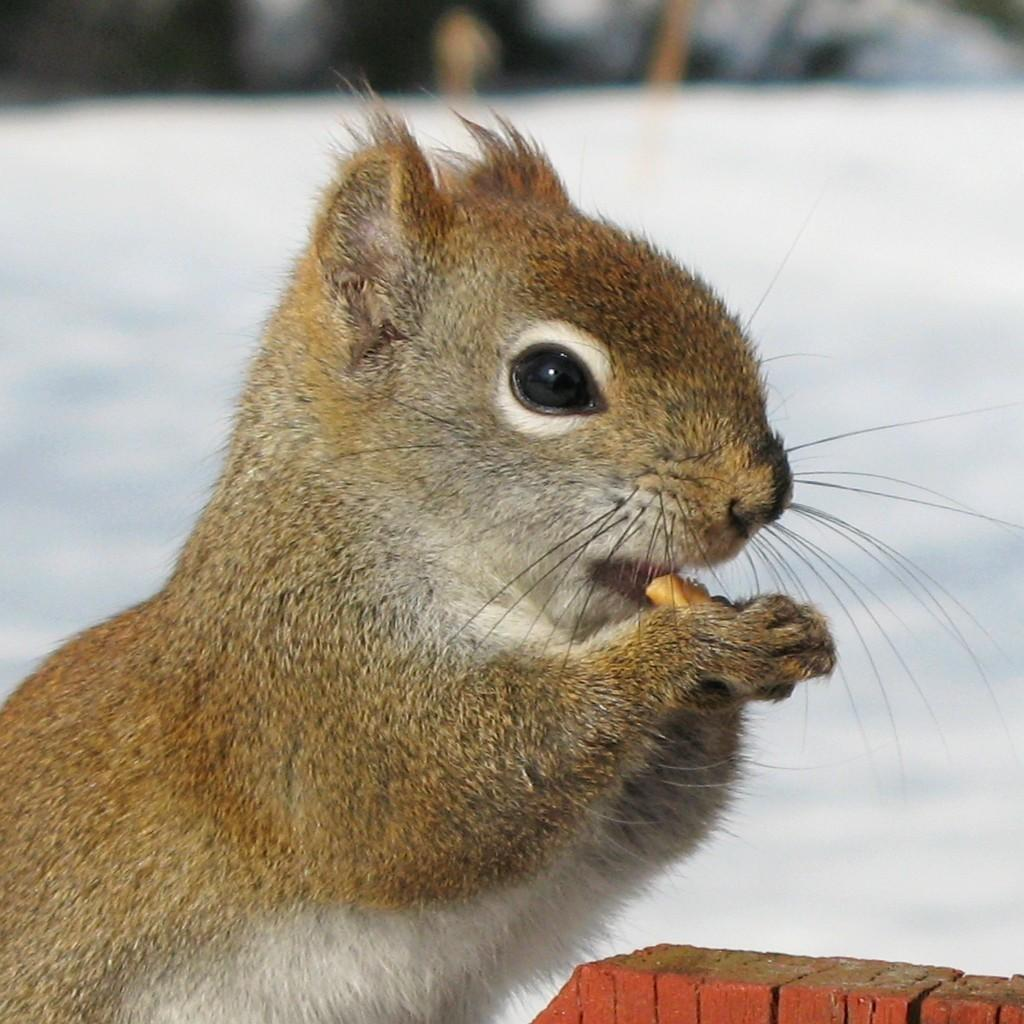What type of animal is in the image? There is a squirrel in the image. What color is the squirrel? The squirrel is brown. How would you describe the squirrel's appearance? The squirrel is cute. What is the squirrel doing in the image? The squirrel is eating a food item. What type of stew is the squirrel cooking in the image? There is no stew or cooking activity present in the image; it features a squirrel eating a food item. What answer is the squirrel providing in the image? There is no indication that the squirrel is providing an answer or engaging in any activity that requires answering a question. 